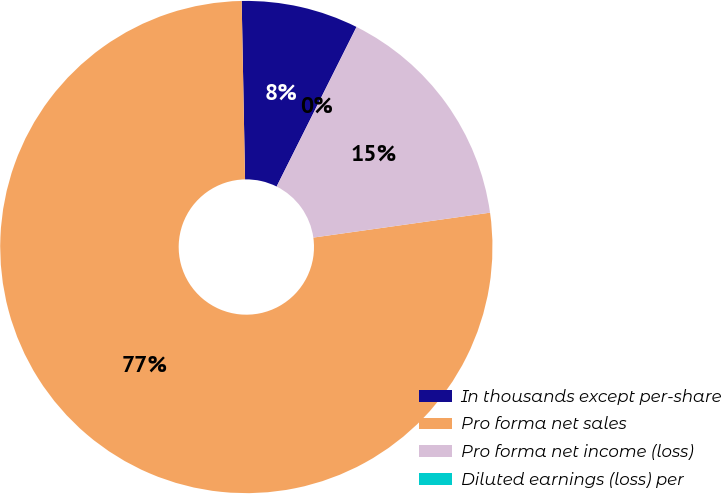Convert chart. <chart><loc_0><loc_0><loc_500><loc_500><pie_chart><fcel>In thousands except per-share<fcel>Pro forma net sales<fcel>Pro forma net income (loss)<fcel>Diluted earnings (loss) per<nl><fcel>7.69%<fcel>76.92%<fcel>15.38%<fcel>0.0%<nl></chart> 